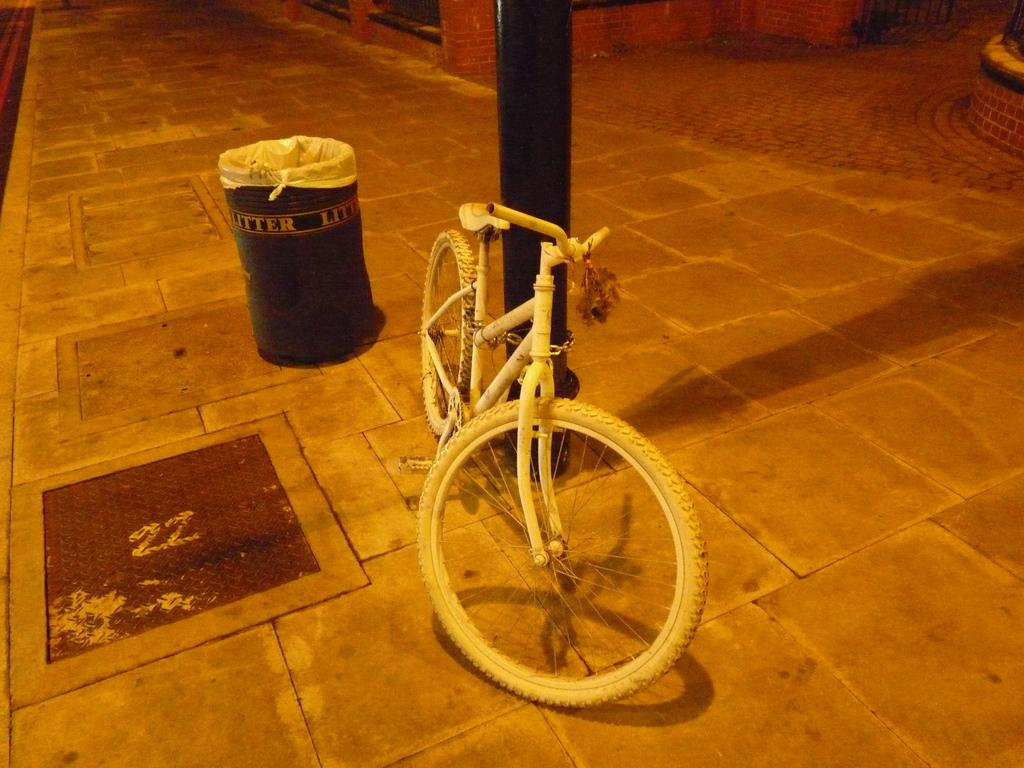What type of vehicle is in the image? There is a bicycle in the image. What other objects can be seen in the image? There is a dustbin, a pole, and a metal door visible in the image. Can you describe the pole in the image? The pole is a vertical structure that can be used for support or as a marker. What is the material of the door in the image? The door in the image is made of metal. What type of owl can be seen perched on the bicycle in the image? There is no owl present in the image; it only features a bicycle, dustbin, pole, and metal door. 